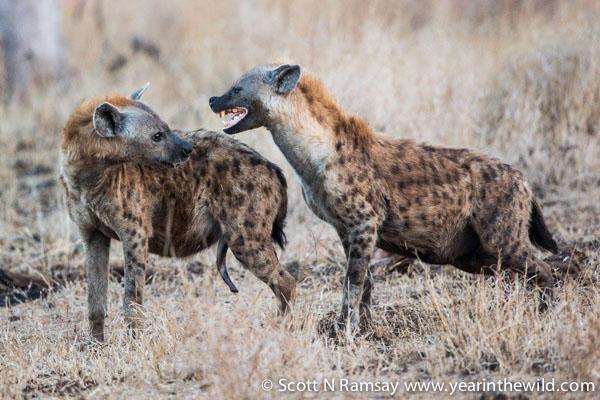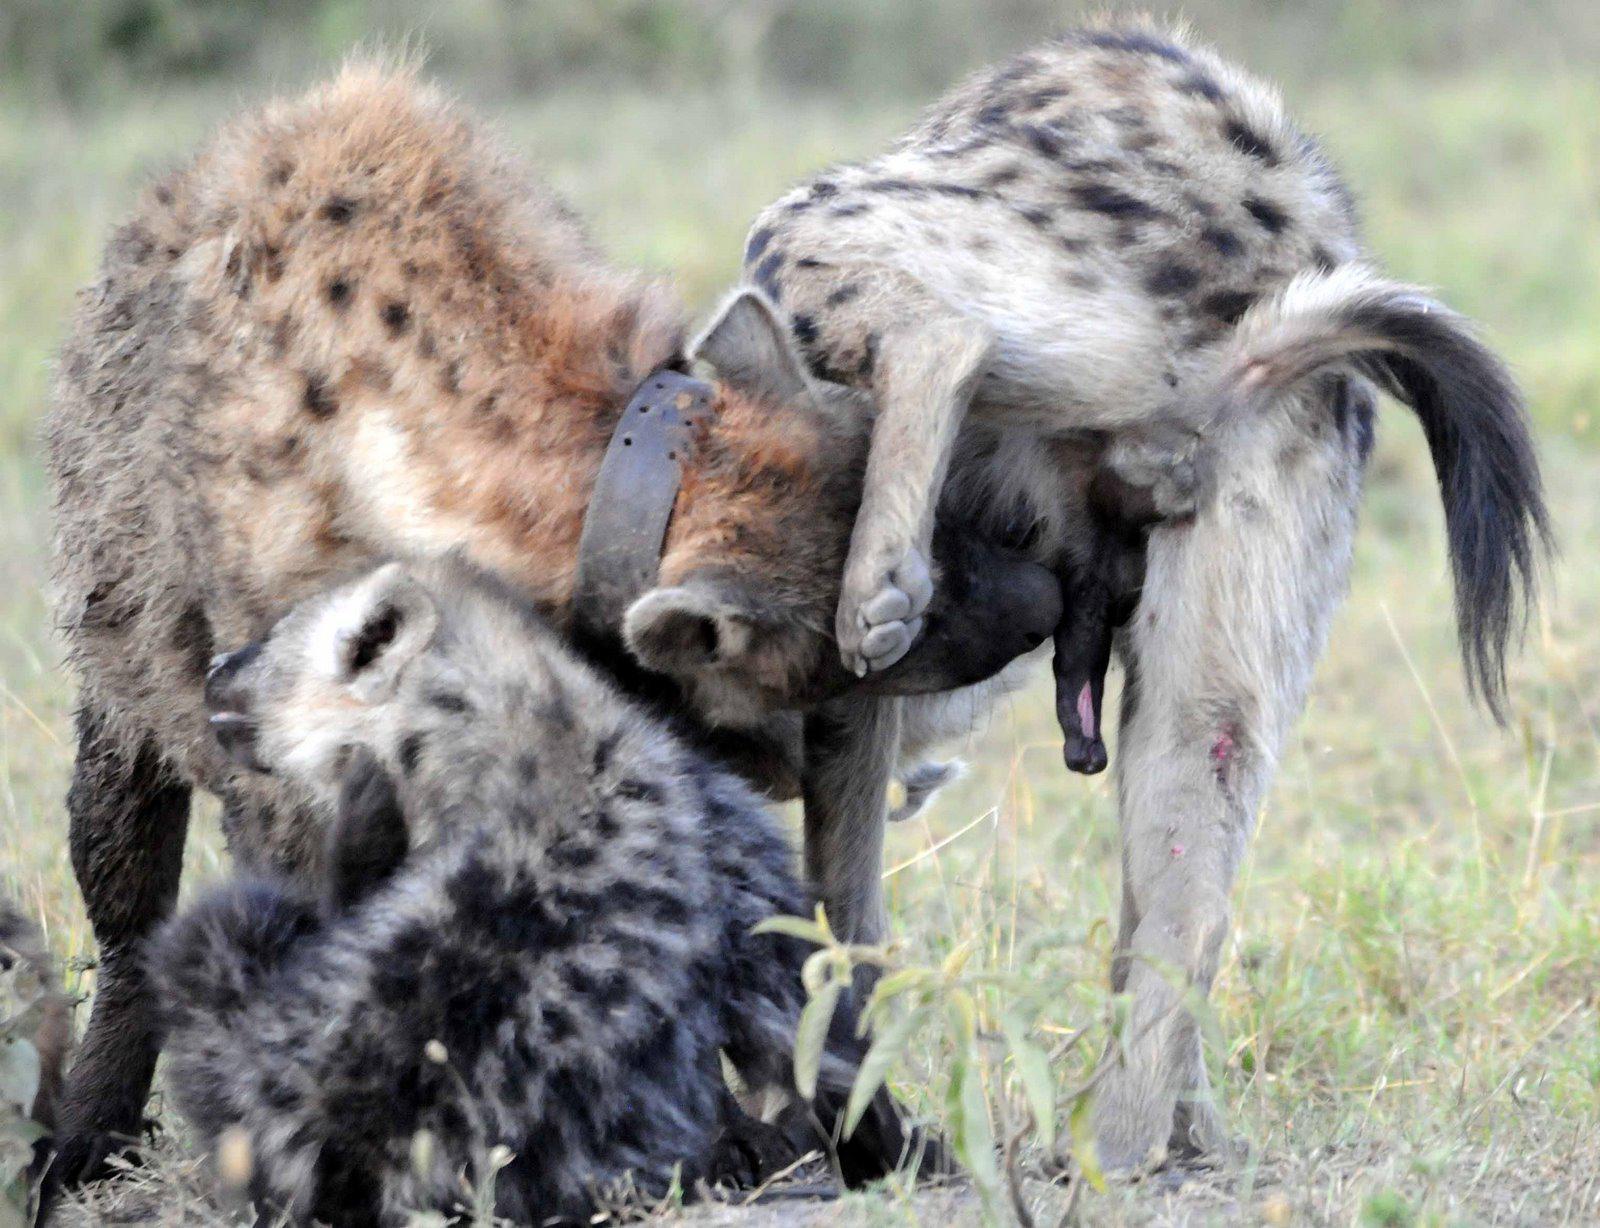The first image is the image on the left, the second image is the image on the right. Assess this claim about the two images: "There are at least two hyenas in each image.". Correct or not? Answer yes or no. Yes. The first image is the image on the left, the second image is the image on the right. Examine the images to the left and right. Is the description "Each image contains multiple hyenas, and one image shows a fang-baring hyena next to one other hyena." accurate? Answer yes or no. Yes. 